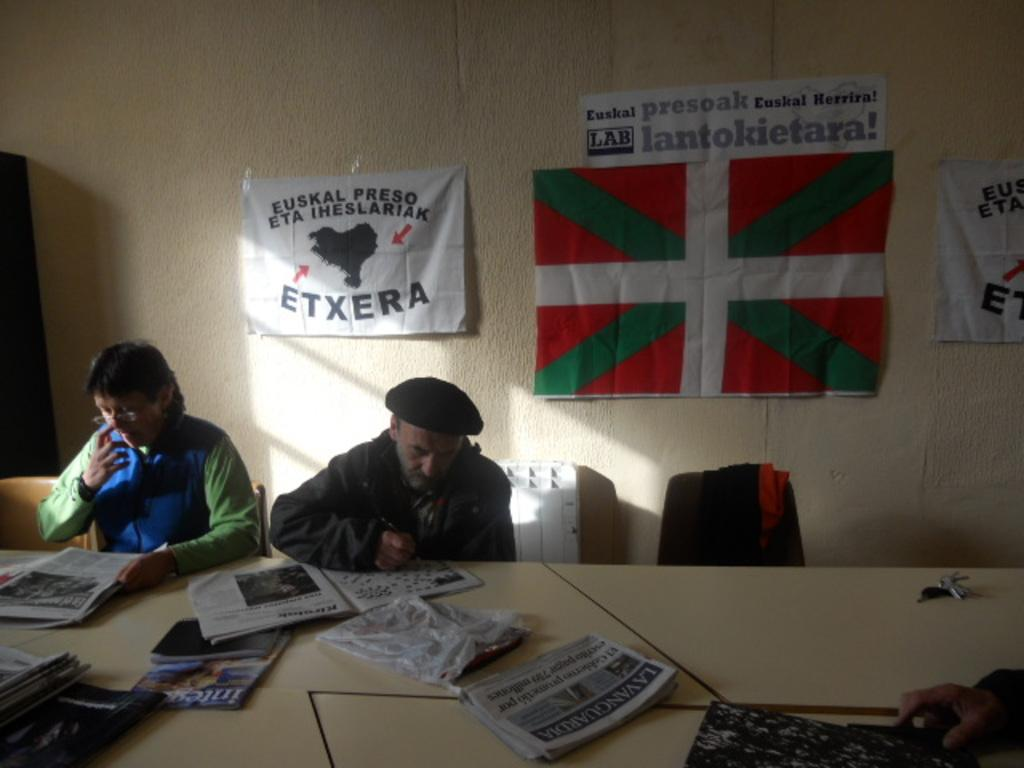How many people are sitting in the image? There are two persons sitting on chairs in the image. What is present between the two sitting persons? There is a table in the image. What is on the table? There are papers on the table. What can be seen in the background of the image? There is a wall in the background of the image. What is on the wall? There are posters on the wall. What type of seed is being planted in the yard in the image? There is no yard or seed present in the image. What thought process can be observed in the image? There is no thought process visible in the image; it only shows two persons sitting, a table, papers, a wall, and posters. 